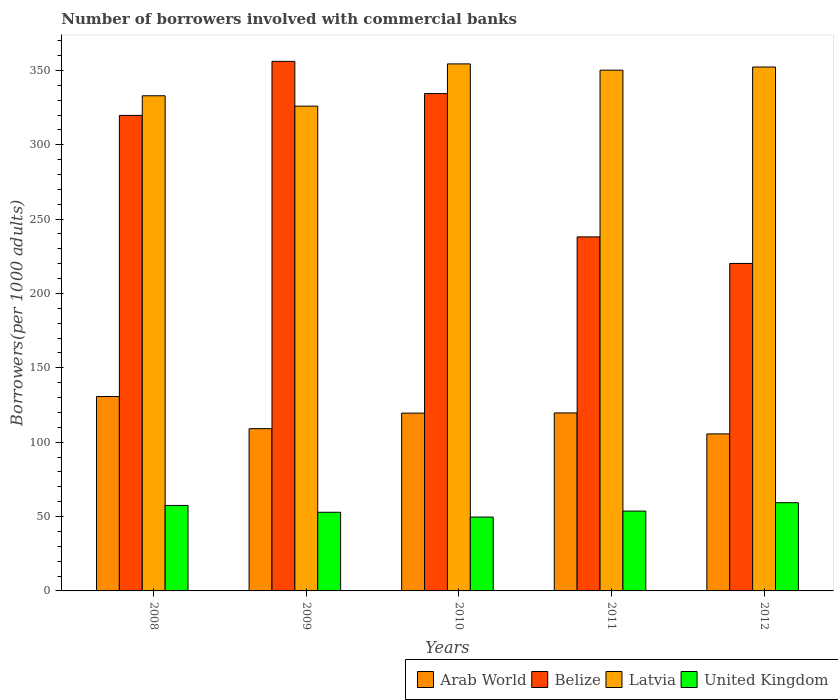How many different coloured bars are there?
Your response must be concise. 4. How many groups of bars are there?
Offer a terse response. 5. Are the number of bars per tick equal to the number of legend labels?
Your answer should be very brief. Yes. What is the number of borrowers involved with commercial banks in United Kingdom in 2010?
Offer a terse response. 49.65. Across all years, what is the maximum number of borrowers involved with commercial banks in Arab World?
Offer a very short reply. 130.7. Across all years, what is the minimum number of borrowers involved with commercial banks in Belize?
Your answer should be very brief. 220.2. What is the total number of borrowers involved with commercial banks in Arab World in the graph?
Your answer should be compact. 584.6. What is the difference between the number of borrowers involved with commercial banks in United Kingdom in 2008 and that in 2011?
Your response must be concise. 3.79. What is the difference between the number of borrowers involved with commercial banks in Arab World in 2008 and the number of borrowers involved with commercial banks in Belize in 2009?
Ensure brevity in your answer.  -225.37. What is the average number of borrowers involved with commercial banks in United Kingdom per year?
Give a very brief answer. 54.6. In the year 2011, what is the difference between the number of borrowers involved with commercial banks in United Kingdom and number of borrowers involved with commercial banks in Arab World?
Keep it short and to the point. -66. What is the ratio of the number of borrowers involved with commercial banks in United Kingdom in 2008 to that in 2011?
Your answer should be compact. 1.07. Is the number of borrowers involved with commercial banks in Arab World in 2008 less than that in 2011?
Keep it short and to the point. No. Is the difference between the number of borrowers involved with commercial banks in United Kingdom in 2009 and 2010 greater than the difference between the number of borrowers involved with commercial banks in Arab World in 2009 and 2010?
Keep it short and to the point. Yes. What is the difference between the highest and the second highest number of borrowers involved with commercial banks in Belize?
Give a very brief answer. 21.67. What is the difference between the highest and the lowest number of borrowers involved with commercial banks in Belize?
Offer a terse response. 135.87. Is the sum of the number of borrowers involved with commercial banks in Latvia in 2009 and 2012 greater than the maximum number of borrowers involved with commercial banks in United Kingdom across all years?
Your answer should be very brief. Yes. Is it the case that in every year, the sum of the number of borrowers involved with commercial banks in United Kingdom and number of borrowers involved with commercial banks in Arab World is greater than the sum of number of borrowers involved with commercial banks in Latvia and number of borrowers involved with commercial banks in Belize?
Offer a very short reply. No. What does the 3rd bar from the left in 2011 represents?
Give a very brief answer. Latvia. What does the 4th bar from the right in 2012 represents?
Offer a terse response. Arab World. Is it the case that in every year, the sum of the number of borrowers involved with commercial banks in United Kingdom and number of borrowers involved with commercial banks in Belize is greater than the number of borrowers involved with commercial banks in Latvia?
Give a very brief answer. No. How many bars are there?
Give a very brief answer. 20. Are all the bars in the graph horizontal?
Provide a short and direct response. No. How many years are there in the graph?
Offer a terse response. 5. What is the difference between two consecutive major ticks on the Y-axis?
Your answer should be very brief. 50. Does the graph contain grids?
Provide a succinct answer. No. Where does the legend appear in the graph?
Your response must be concise. Bottom right. How many legend labels are there?
Offer a terse response. 4. What is the title of the graph?
Your answer should be very brief. Number of borrowers involved with commercial banks. Does "Turkmenistan" appear as one of the legend labels in the graph?
Your answer should be compact. No. What is the label or title of the Y-axis?
Your answer should be compact. Borrowers(per 1000 adults). What is the Borrowers(per 1000 adults) of Arab World in 2008?
Your response must be concise. 130.7. What is the Borrowers(per 1000 adults) of Belize in 2008?
Your response must be concise. 319.74. What is the Borrowers(per 1000 adults) in Latvia in 2008?
Your answer should be compact. 332.93. What is the Borrowers(per 1000 adults) in United Kingdom in 2008?
Make the answer very short. 57.47. What is the Borrowers(per 1000 adults) in Arab World in 2009?
Ensure brevity in your answer.  109.1. What is the Borrowers(per 1000 adults) of Belize in 2009?
Your response must be concise. 356.07. What is the Borrowers(per 1000 adults) of Latvia in 2009?
Your response must be concise. 325.95. What is the Borrowers(per 1000 adults) in United Kingdom in 2009?
Offer a very short reply. 52.88. What is the Borrowers(per 1000 adults) of Arab World in 2010?
Keep it short and to the point. 119.55. What is the Borrowers(per 1000 adults) in Belize in 2010?
Provide a succinct answer. 334.41. What is the Borrowers(per 1000 adults) in Latvia in 2010?
Offer a terse response. 354.36. What is the Borrowers(per 1000 adults) in United Kingdom in 2010?
Keep it short and to the point. 49.65. What is the Borrowers(per 1000 adults) of Arab World in 2011?
Ensure brevity in your answer.  119.68. What is the Borrowers(per 1000 adults) in Belize in 2011?
Provide a short and direct response. 238.05. What is the Borrowers(per 1000 adults) in Latvia in 2011?
Offer a terse response. 350.14. What is the Borrowers(per 1000 adults) in United Kingdom in 2011?
Give a very brief answer. 53.68. What is the Borrowers(per 1000 adults) of Arab World in 2012?
Give a very brief answer. 105.58. What is the Borrowers(per 1000 adults) of Belize in 2012?
Ensure brevity in your answer.  220.2. What is the Borrowers(per 1000 adults) in Latvia in 2012?
Offer a very short reply. 352.26. What is the Borrowers(per 1000 adults) of United Kingdom in 2012?
Your response must be concise. 59.32. Across all years, what is the maximum Borrowers(per 1000 adults) of Arab World?
Make the answer very short. 130.7. Across all years, what is the maximum Borrowers(per 1000 adults) of Belize?
Make the answer very short. 356.07. Across all years, what is the maximum Borrowers(per 1000 adults) in Latvia?
Ensure brevity in your answer.  354.36. Across all years, what is the maximum Borrowers(per 1000 adults) in United Kingdom?
Provide a succinct answer. 59.32. Across all years, what is the minimum Borrowers(per 1000 adults) of Arab World?
Your answer should be very brief. 105.58. Across all years, what is the minimum Borrowers(per 1000 adults) in Belize?
Ensure brevity in your answer.  220.2. Across all years, what is the minimum Borrowers(per 1000 adults) of Latvia?
Provide a succinct answer. 325.95. Across all years, what is the minimum Borrowers(per 1000 adults) in United Kingdom?
Offer a very short reply. 49.65. What is the total Borrowers(per 1000 adults) of Arab World in the graph?
Keep it short and to the point. 584.6. What is the total Borrowers(per 1000 adults) of Belize in the graph?
Offer a terse response. 1468.47. What is the total Borrowers(per 1000 adults) in Latvia in the graph?
Give a very brief answer. 1715.64. What is the total Borrowers(per 1000 adults) of United Kingdom in the graph?
Your answer should be very brief. 273. What is the difference between the Borrowers(per 1000 adults) in Arab World in 2008 and that in 2009?
Your answer should be compact. 21.6. What is the difference between the Borrowers(per 1000 adults) in Belize in 2008 and that in 2009?
Give a very brief answer. -36.33. What is the difference between the Borrowers(per 1000 adults) in Latvia in 2008 and that in 2009?
Provide a short and direct response. 6.98. What is the difference between the Borrowers(per 1000 adults) in United Kingdom in 2008 and that in 2009?
Keep it short and to the point. 4.59. What is the difference between the Borrowers(per 1000 adults) in Arab World in 2008 and that in 2010?
Provide a short and direct response. 11.15. What is the difference between the Borrowers(per 1000 adults) in Belize in 2008 and that in 2010?
Give a very brief answer. -14.67. What is the difference between the Borrowers(per 1000 adults) in Latvia in 2008 and that in 2010?
Your answer should be very brief. -21.43. What is the difference between the Borrowers(per 1000 adults) of United Kingdom in 2008 and that in 2010?
Your answer should be very brief. 7.83. What is the difference between the Borrowers(per 1000 adults) in Arab World in 2008 and that in 2011?
Provide a succinct answer. 11.02. What is the difference between the Borrowers(per 1000 adults) of Belize in 2008 and that in 2011?
Give a very brief answer. 81.69. What is the difference between the Borrowers(per 1000 adults) of Latvia in 2008 and that in 2011?
Give a very brief answer. -17.21. What is the difference between the Borrowers(per 1000 adults) in United Kingdom in 2008 and that in 2011?
Offer a very short reply. 3.79. What is the difference between the Borrowers(per 1000 adults) in Arab World in 2008 and that in 2012?
Your response must be concise. 25.12. What is the difference between the Borrowers(per 1000 adults) in Belize in 2008 and that in 2012?
Your answer should be compact. 99.53. What is the difference between the Borrowers(per 1000 adults) of Latvia in 2008 and that in 2012?
Make the answer very short. -19.32. What is the difference between the Borrowers(per 1000 adults) of United Kingdom in 2008 and that in 2012?
Give a very brief answer. -1.85. What is the difference between the Borrowers(per 1000 adults) in Arab World in 2009 and that in 2010?
Your answer should be compact. -10.45. What is the difference between the Borrowers(per 1000 adults) in Belize in 2009 and that in 2010?
Ensure brevity in your answer.  21.67. What is the difference between the Borrowers(per 1000 adults) of Latvia in 2009 and that in 2010?
Give a very brief answer. -28.41. What is the difference between the Borrowers(per 1000 adults) in United Kingdom in 2009 and that in 2010?
Your answer should be compact. 3.23. What is the difference between the Borrowers(per 1000 adults) in Arab World in 2009 and that in 2011?
Provide a short and direct response. -10.58. What is the difference between the Borrowers(per 1000 adults) in Belize in 2009 and that in 2011?
Offer a terse response. 118.03. What is the difference between the Borrowers(per 1000 adults) in Latvia in 2009 and that in 2011?
Your response must be concise. -24.19. What is the difference between the Borrowers(per 1000 adults) of United Kingdom in 2009 and that in 2011?
Provide a succinct answer. -0.8. What is the difference between the Borrowers(per 1000 adults) in Arab World in 2009 and that in 2012?
Your response must be concise. 3.52. What is the difference between the Borrowers(per 1000 adults) of Belize in 2009 and that in 2012?
Offer a terse response. 135.87. What is the difference between the Borrowers(per 1000 adults) in Latvia in 2009 and that in 2012?
Offer a terse response. -26.3. What is the difference between the Borrowers(per 1000 adults) of United Kingdom in 2009 and that in 2012?
Give a very brief answer. -6.44. What is the difference between the Borrowers(per 1000 adults) of Arab World in 2010 and that in 2011?
Keep it short and to the point. -0.13. What is the difference between the Borrowers(per 1000 adults) in Belize in 2010 and that in 2011?
Make the answer very short. 96.36. What is the difference between the Borrowers(per 1000 adults) of Latvia in 2010 and that in 2011?
Your response must be concise. 4.22. What is the difference between the Borrowers(per 1000 adults) of United Kingdom in 2010 and that in 2011?
Offer a very short reply. -4.03. What is the difference between the Borrowers(per 1000 adults) in Arab World in 2010 and that in 2012?
Provide a short and direct response. 13.97. What is the difference between the Borrowers(per 1000 adults) of Belize in 2010 and that in 2012?
Make the answer very short. 114.2. What is the difference between the Borrowers(per 1000 adults) in Latvia in 2010 and that in 2012?
Give a very brief answer. 2.11. What is the difference between the Borrowers(per 1000 adults) of United Kingdom in 2010 and that in 2012?
Give a very brief answer. -9.67. What is the difference between the Borrowers(per 1000 adults) of Arab World in 2011 and that in 2012?
Provide a short and direct response. 14.1. What is the difference between the Borrowers(per 1000 adults) of Belize in 2011 and that in 2012?
Offer a very short reply. 17.84. What is the difference between the Borrowers(per 1000 adults) in Latvia in 2011 and that in 2012?
Your answer should be compact. -2.12. What is the difference between the Borrowers(per 1000 adults) in United Kingdom in 2011 and that in 2012?
Give a very brief answer. -5.64. What is the difference between the Borrowers(per 1000 adults) in Arab World in 2008 and the Borrowers(per 1000 adults) in Belize in 2009?
Give a very brief answer. -225.38. What is the difference between the Borrowers(per 1000 adults) of Arab World in 2008 and the Borrowers(per 1000 adults) of Latvia in 2009?
Offer a very short reply. -195.25. What is the difference between the Borrowers(per 1000 adults) in Arab World in 2008 and the Borrowers(per 1000 adults) in United Kingdom in 2009?
Offer a very short reply. 77.82. What is the difference between the Borrowers(per 1000 adults) in Belize in 2008 and the Borrowers(per 1000 adults) in Latvia in 2009?
Provide a short and direct response. -6.21. What is the difference between the Borrowers(per 1000 adults) of Belize in 2008 and the Borrowers(per 1000 adults) of United Kingdom in 2009?
Make the answer very short. 266.86. What is the difference between the Borrowers(per 1000 adults) in Latvia in 2008 and the Borrowers(per 1000 adults) in United Kingdom in 2009?
Keep it short and to the point. 280.05. What is the difference between the Borrowers(per 1000 adults) of Arab World in 2008 and the Borrowers(per 1000 adults) of Belize in 2010?
Your answer should be compact. -203.71. What is the difference between the Borrowers(per 1000 adults) in Arab World in 2008 and the Borrowers(per 1000 adults) in Latvia in 2010?
Keep it short and to the point. -223.66. What is the difference between the Borrowers(per 1000 adults) of Arab World in 2008 and the Borrowers(per 1000 adults) of United Kingdom in 2010?
Your answer should be very brief. 81.05. What is the difference between the Borrowers(per 1000 adults) in Belize in 2008 and the Borrowers(per 1000 adults) in Latvia in 2010?
Offer a terse response. -34.62. What is the difference between the Borrowers(per 1000 adults) of Belize in 2008 and the Borrowers(per 1000 adults) of United Kingdom in 2010?
Your answer should be very brief. 270.09. What is the difference between the Borrowers(per 1000 adults) of Latvia in 2008 and the Borrowers(per 1000 adults) of United Kingdom in 2010?
Make the answer very short. 283.29. What is the difference between the Borrowers(per 1000 adults) in Arab World in 2008 and the Borrowers(per 1000 adults) in Belize in 2011?
Give a very brief answer. -107.35. What is the difference between the Borrowers(per 1000 adults) of Arab World in 2008 and the Borrowers(per 1000 adults) of Latvia in 2011?
Ensure brevity in your answer.  -219.44. What is the difference between the Borrowers(per 1000 adults) of Arab World in 2008 and the Borrowers(per 1000 adults) of United Kingdom in 2011?
Your answer should be very brief. 77.02. What is the difference between the Borrowers(per 1000 adults) of Belize in 2008 and the Borrowers(per 1000 adults) of Latvia in 2011?
Provide a short and direct response. -30.4. What is the difference between the Borrowers(per 1000 adults) in Belize in 2008 and the Borrowers(per 1000 adults) in United Kingdom in 2011?
Provide a succinct answer. 266.06. What is the difference between the Borrowers(per 1000 adults) in Latvia in 2008 and the Borrowers(per 1000 adults) in United Kingdom in 2011?
Your answer should be very brief. 279.25. What is the difference between the Borrowers(per 1000 adults) of Arab World in 2008 and the Borrowers(per 1000 adults) of Belize in 2012?
Ensure brevity in your answer.  -89.51. What is the difference between the Borrowers(per 1000 adults) in Arab World in 2008 and the Borrowers(per 1000 adults) in Latvia in 2012?
Your answer should be very brief. -221.56. What is the difference between the Borrowers(per 1000 adults) of Arab World in 2008 and the Borrowers(per 1000 adults) of United Kingdom in 2012?
Your answer should be very brief. 71.38. What is the difference between the Borrowers(per 1000 adults) in Belize in 2008 and the Borrowers(per 1000 adults) in Latvia in 2012?
Your response must be concise. -32.52. What is the difference between the Borrowers(per 1000 adults) in Belize in 2008 and the Borrowers(per 1000 adults) in United Kingdom in 2012?
Make the answer very short. 260.42. What is the difference between the Borrowers(per 1000 adults) of Latvia in 2008 and the Borrowers(per 1000 adults) of United Kingdom in 2012?
Provide a short and direct response. 273.61. What is the difference between the Borrowers(per 1000 adults) of Arab World in 2009 and the Borrowers(per 1000 adults) of Belize in 2010?
Offer a terse response. -225.31. What is the difference between the Borrowers(per 1000 adults) in Arab World in 2009 and the Borrowers(per 1000 adults) in Latvia in 2010?
Make the answer very short. -245.26. What is the difference between the Borrowers(per 1000 adults) in Arab World in 2009 and the Borrowers(per 1000 adults) in United Kingdom in 2010?
Provide a short and direct response. 59.45. What is the difference between the Borrowers(per 1000 adults) of Belize in 2009 and the Borrowers(per 1000 adults) of Latvia in 2010?
Keep it short and to the point. 1.71. What is the difference between the Borrowers(per 1000 adults) in Belize in 2009 and the Borrowers(per 1000 adults) in United Kingdom in 2010?
Your answer should be very brief. 306.42. What is the difference between the Borrowers(per 1000 adults) in Latvia in 2009 and the Borrowers(per 1000 adults) in United Kingdom in 2010?
Offer a very short reply. 276.3. What is the difference between the Borrowers(per 1000 adults) in Arab World in 2009 and the Borrowers(per 1000 adults) in Belize in 2011?
Ensure brevity in your answer.  -128.95. What is the difference between the Borrowers(per 1000 adults) of Arab World in 2009 and the Borrowers(per 1000 adults) of Latvia in 2011?
Give a very brief answer. -241.04. What is the difference between the Borrowers(per 1000 adults) in Arab World in 2009 and the Borrowers(per 1000 adults) in United Kingdom in 2011?
Give a very brief answer. 55.42. What is the difference between the Borrowers(per 1000 adults) of Belize in 2009 and the Borrowers(per 1000 adults) of Latvia in 2011?
Your answer should be very brief. 5.93. What is the difference between the Borrowers(per 1000 adults) of Belize in 2009 and the Borrowers(per 1000 adults) of United Kingdom in 2011?
Your answer should be compact. 302.39. What is the difference between the Borrowers(per 1000 adults) in Latvia in 2009 and the Borrowers(per 1000 adults) in United Kingdom in 2011?
Your answer should be compact. 272.27. What is the difference between the Borrowers(per 1000 adults) of Arab World in 2009 and the Borrowers(per 1000 adults) of Belize in 2012?
Offer a very short reply. -111.11. What is the difference between the Borrowers(per 1000 adults) of Arab World in 2009 and the Borrowers(per 1000 adults) of Latvia in 2012?
Give a very brief answer. -243.16. What is the difference between the Borrowers(per 1000 adults) in Arab World in 2009 and the Borrowers(per 1000 adults) in United Kingdom in 2012?
Give a very brief answer. 49.78. What is the difference between the Borrowers(per 1000 adults) of Belize in 2009 and the Borrowers(per 1000 adults) of Latvia in 2012?
Offer a terse response. 3.82. What is the difference between the Borrowers(per 1000 adults) in Belize in 2009 and the Borrowers(per 1000 adults) in United Kingdom in 2012?
Make the answer very short. 296.75. What is the difference between the Borrowers(per 1000 adults) of Latvia in 2009 and the Borrowers(per 1000 adults) of United Kingdom in 2012?
Your answer should be very brief. 266.63. What is the difference between the Borrowers(per 1000 adults) of Arab World in 2010 and the Borrowers(per 1000 adults) of Belize in 2011?
Offer a very short reply. -118.5. What is the difference between the Borrowers(per 1000 adults) in Arab World in 2010 and the Borrowers(per 1000 adults) in Latvia in 2011?
Keep it short and to the point. -230.59. What is the difference between the Borrowers(per 1000 adults) in Arab World in 2010 and the Borrowers(per 1000 adults) in United Kingdom in 2011?
Provide a succinct answer. 65.87. What is the difference between the Borrowers(per 1000 adults) in Belize in 2010 and the Borrowers(per 1000 adults) in Latvia in 2011?
Make the answer very short. -15.73. What is the difference between the Borrowers(per 1000 adults) in Belize in 2010 and the Borrowers(per 1000 adults) in United Kingdom in 2011?
Your answer should be very brief. 280.73. What is the difference between the Borrowers(per 1000 adults) in Latvia in 2010 and the Borrowers(per 1000 adults) in United Kingdom in 2011?
Keep it short and to the point. 300.68. What is the difference between the Borrowers(per 1000 adults) of Arab World in 2010 and the Borrowers(per 1000 adults) of Belize in 2012?
Provide a short and direct response. -100.65. What is the difference between the Borrowers(per 1000 adults) of Arab World in 2010 and the Borrowers(per 1000 adults) of Latvia in 2012?
Offer a terse response. -232.71. What is the difference between the Borrowers(per 1000 adults) in Arab World in 2010 and the Borrowers(per 1000 adults) in United Kingdom in 2012?
Your response must be concise. 60.23. What is the difference between the Borrowers(per 1000 adults) of Belize in 2010 and the Borrowers(per 1000 adults) of Latvia in 2012?
Keep it short and to the point. -17.85. What is the difference between the Borrowers(per 1000 adults) of Belize in 2010 and the Borrowers(per 1000 adults) of United Kingdom in 2012?
Make the answer very short. 275.09. What is the difference between the Borrowers(per 1000 adults) in Latvia in 2010 and the Borrowers(per 1000 adults) in United Kingdom in 2012?
Offer a very short reply. 295.04. What is the difference between the Borrowers(per 1000 adults) of Arab World in 2011 and the Borrowers(per 1000 adults) of Belize in 2012?
Make the answer very short. -100.52. What is the difference between the Borrowers(per 1000 adults) of Arab World in 2011 and the Borrowers(per 1000 adults) of Latvia in 2012?
Your answer should be very brief. -232.58. What is the difference between the Borrowers(per 1000 adults) of Arab World in 2011 and the Borrowers(per 1000 adults) of United Kingdom in 2012?
Provide a succinct answer. 60.36. What is the difference between the Borrowers(per 1000 adults) of Belize in 2011 and the Borrowers(per 1000 adults) of Latvia in 2012?
Give a very brief answer. -114.21. What is the difference between the Borrowers(per 1000 adults) of Belize in 2011 and the Borrowers(per 1000 adults) of United Kingdom in 2012?
Your answer should be very brief. 178.72. What is the difference between the Borrowers(per 1000 adults) in Latvia in 2011 and the Borrowers(per 1000 adults) in United Kingdom in 2012?
Provide a succinct answer. 290.82. What is the average Borrowers(per 1000 adults) in Arab World per year?
Ensure brevity in your answer.  116.92. What is the average Borrowers(per 1000 adults) of Belize per year?
Provide a short and direct response. 293.69. What is the average Borrowers(per 1000 adults) in Latvia per year?
Make the answer very short. 343.13. What is the average Borrowers(per 1000 adults) of United Kingdom per year?
Offer a very short reply. 54.6. In the year 2008, what is the difference between the Borrowers(per 1000 adults) in Arab World and Borrowers(per 1000 adults) in Belize?
Offer a very short reply. -189.04. In the year 2008, what is the difference between the Borrowers(per 1000 adults) of Arab World and Borrowers(per 1000 adults) of Latvia?
Keep it short and to the point. -202.24. In the year 2008, what is the difference between the Borrowers(per 1000 adults) of Arab World and Borrowers(per 1000 adults) of United Kingdom?
Ensure brevity in your answer.  73.22. In the year 2008, what is the difference between the Borrowers(per 1000 adults) of Belize and Borrowers(per 1000 adults) of Latvia?
Your response must be concise. -13.19. In the year 2008, what is the difference between the Borrowers(per 1000 adults) of Belize and Borrowers(per 1000 adults) of United Kingdom?
Keep it short and to the point. 262.26. In the year 2008, what is the difference between the Borrowers(per 1000 adults) of Latvia and Borrowers(per 1000 adults) of United Kingdom?
Provide a short and direct response. 275.46. In the year 2009, what is the difference between the Borrowers(per 1000 adults) of Arab World and Borrowers(per 1000 adults) of Belize?
Your answer should be compact. -246.98. In the year 2009, what is the difference between the Borrowers(per 1000 adults) in Arab World and Borrowers(per 1000 adults) in Latvia?
Your answer should be very brief. -216.85. In the year 2009, what is the difference between the Borrowers(per 1000 adults) of Arab World and Borrowers(per 1000 adults) of United Kingdom?
Ensure brevity in your answer.  56.22. In the year 2009, what is the difference between the Borrowers(per 1000 adults) of Belize and Borrowers(per 1000 adults) of Latvia?
Ensure brevity in your answer.  30.12. In the year 2009, what is the difference between the Borrowers(per 1000 adults) of Belize and Borrowers(per 1000 adults) of United Kingdom?
Give a very brief answer. 303.19. In the year 2009, what is the difference between the Borrowers(per 1000 adults) in Latvia and Borrowers(per 1000 adults) in United Kingdom?
Keep it short and to the point. 273.07. In the year 2010, what is the difference between the Borrowers(per 1000 adults) of Arab World and Borrowers(per 1000 adults) of Belize?
Give a very brief answer. -214.86. In the year 2010, what is the difference between the Borrowers(per 1000 adults) of Arab World and Borrowers(per 1000 adults) of Latvia?
Ensure brevity in your answer.  -234.81. In the year 2010, what is the difference between the Borrowers(per 1000 adults) of Arab World and Borrowers(per 1000 adults) of United Kingdom?
Your answer should be very brief. 69.9. In the year 2010, what is the difference between the Borrowers(per 1000 adults) in Belize and Borrowers(per 1000 adults) in Latvia?
Make the answer very short. -19.96. In the year 2010, what is the difference between the Borrowers(per 1000 adults) in Belize and Borrowers(per 1000 adults) in United Kingdom?
Offer a very short reply. 284.76. In the year 2010, what is the difference between the Borrowers(per 1000 adults) in Latvia and Borrowers(per 1000 adults) in United Kingdom?
Your answer should be very brief. 304.71. In the year 2011, what is the difference between the Borrowers(per 1000 adults) of Arab World and Borrowers(per 1000 adults) of Belize?
Your answer should be compact. -118.37. In the year 2011, what is the difference between the Borrowers(per 1000 adults) of Arab World and Borrowers(per 1000 adults) of Latvia?
Your answer should be compact. -230.46. In the year 2011, what is the difference between the Borrowers(per 1000 adults) in Arab World and Borrowers(per 1000 adults) in United Kingdom?
Provide a succinct answer. 66. In the year 2011, what is the difference between the Borrowers(per 1000 adults) of Belize and Borrowers(per 1000 adults) of Latvia?
Provide a short and direct response. -112.09. In the year 2011, what is the difference between the Borrowers(per 1000 adults) in Belize and Borrowers(per 1000 adults) in United Kingdom?
Provide a short and direct response. 184.37. In the year 2011, what is the difference between the Borrowers(per 1000 adults) of Latvia and Borrowers(per 1000 adults) of United Kingdom?
Your response must be concise. 296.46. In the year 2012, what is the difference between the Borrowers(per 1000 adults) of Arab World and Borrowers(per 1000 adults) of Belize?
Give a very brief answer. -114.62. In the year 2012, what is the difference between the Borrowers(per 1000 adults) in Arab World and Borrowers(per 1000 adults) in Latvia?
Offer a terse response. -246.68. In the year 2012, what is the difference between the Borrowers(per 1000 adults) in Arab World and Borrowers(per 1000 adults) in United Kingdom?
Give a very brief answer. 46.26. In the year 2012, what is the difference between the Borrowers(per 1000 adults) in Belize and Borrowers(per 1000 adults) in Latvia?
Your response must be concise. -132.05. In the year 2012, what is the difference between the Borrowers(per 1000 adults) of Belize and Borrowers(per 1000 adults) of United Kingdom?
Your answer should be compact. 160.88. In the year 2012, what is the difference between the Borrowers(per 1000 adults) in Latvia and Borrowers(per 1000 adults) in United Kingdom?
Your answer should be very brief. 292.94. What is the ratio of the Borrowers(per 1000 adults) in Arab World in 2008 to that in 2009?
Your answer should be very brief. 1.2. What is the ratio of the Borrowers(per 1000 adults) in Belize in 2008 to that in 2009?
Make the answer very short. 0.9. What is the ratio of the Borrowers(per 1000 adults) of Latvia in 2008 to that in 2009?
Your answer should be very brief. 1.02. What is the ratio of the Borrowers(per 1000 adults) in United Kingdom in 2008 to that in 2009?
Offer a very short reply. 1.09. What is the ratio of the Borrowers(per 1000 adults) of Arab World in 2008 to that in 2010?
Give a very brief answer. 1.09. What is the ratio of the Borrowers(per 1000 adults) of Belize in 2008 to that in 2010?
Offer a terse response. 0.96. What is the ratio of the Borrowers(per 1000 adults) in Latvia in 2008 to that in 2010?
Provide a short and direct response. 0.94. What is the ratio of the Borrowers(per 1000 adults) of United Kingdom in 2008 to that in 2010?
Provide a succinct answer. 1.16. What is the ratio of the Borrowers(per 1000 adults) in Arab World in 2008 to that in 2011?
Provide a short and direct response. 1.09. What is the ratio of the Borrowers(per 1000 adults) in Belize in 2008 to that in 2011?
Offer a terse response. 1.34. What is the ratio of the Borrowers(per 1000 adults) of Latvia in 2008 to that in 2011?
Provide a short and direct response. 0.95. What is the ratio of the Borrowers(per 1000 adults) in United Kingdom in 2008 to that in 2011?
Your answer should be compact. 1.07. What is the ratio of the Borrowers(per 1000 adults) of Arab World in 2008 to that in 2012?
Your answer should be very brief. 1.24. What is the ratio of the Borrowers(per 1000 adults) of Belize in 2008 to that in 2012?
Offer a very short reply. 1.45. What is the ratio of the Borrowers(per 1000 adults) of Latvia in 2008 to that in 2012?
Your response must be concise. 0.95. What is the ratio of the Borrowers(per 1000 adults) of United Kingdom in 2008 to that in 2012?
Give a very brief answer. 0.97. What is the ratio of the Borrowers(per 1000 adults) of Arab World in 2009 to that in 2010?
Give a very brief answer. 0.91. What is the ratio of the Borrowers(per 1000 adults) of Belize in 2009 to that in 2010?
Ensure brevity in your answer.  1.06. What is the ratio of the Borrowers(per 1000 adults) in Latvia in 2009 to that in 2010?
Offer a very short reply. 0.92. What is the ratio of the Borrowers(per 1000 adults) of United Kingdom in 2009 to that in 2010?
Ensure brevity in your answer.  1.07. What is the ratio of the Borrowers(per 1000 adults) in Arab World in 2009 to that in 2011?
Provide a short and direct response. 0.91. What is the ratio of the Borrowers(per 1000 adults) of Belize in 2009 to that in 2011?
Provide a short and direct response. 1.5. What is the ratio of the Borrowers(per 1000 adults) of Latvia in 2009 to that in 2011?
Make the answer very short. 0.93. What is the ratio of the Borrowers(per 1000 adults) in United Kingdom in 2009 to that in 2011?
Make the answer very short. 0.99. What is the ratio of the Borrowers(per 1000 adults) in Arab World in 2009 to that in 2012?
Make the answer very short. 1.03. What is the ratio of the Borrowers(per 1000 adults) in Belize in 2009 to that in 2012?
Give a very brief answer. 1.62. What is the ratio of the Borrowers(per 1000 adults) of Latvia in 2009 to that in 2012?
Your response must be concise. 0.93. What is the ratio of the Borrowers(per 1000 adults) in United Kingdom in 2009 to that in 2012?
Keep it short and to the point. 0.89. What is the ratio of the Borrowers(per 1000 adults) of Arab World in 2010 to that in 2011?
Ensure brevity in your answer.  1. What is the ratio of the Borrowers(per 1000 adults) in Belize in 2010 to that in 2011?
Make the answer very short. 1.4. What is the ratio of the Borrowers(per 1000 adults) in Latvia in 2010 to that in 2011?
Offer a very short reply. 1.01. What is the ratio of the Borrowers(per 1000 adults) in United Kingdom in 2010 to that in 2011?
Make the answer very short. 0.92. What is the ratio of the Borrowers(per 1000 adults) of Arab World in 2010 to that in 2012?
Ensure brevity in your answer.  1.13. What is the ratio of the Borrowers(per 1000 adults) of Belize in 2010 to that in 2012?
Ensure brevity in your answer.  1.52. What is the ratio of the Borrowers(per 1000 adults) in Latvia in 2010 to that in 2012?
Make the answer very short. 1.01. What is the ratio of the Borrowers(per 1000 adults) of United Kingdom in 2010 to that in 2012?
Your answer should be compact. 0.84. What is the ratio of the Borrowers(per 1000 adults) of Arab World in 2011 to that in 2012?
Provide a succinct answer. 1.13. What is the ratio of the Borrowers(per 1000 adults) in Belize in 2011 to that in 2012?
Your response must be concise. 1.08. What is the ratio of the Borrowers(per 1000 adults) of United Kingdom in 2011 to that in 2012?
Provide a short and direct response. 0.9. What is the difference between the highest and the second highest Borrowers(per 1000 adults) in Arab World?
Your answer should be compact. 11.02. What is the difference between the highest and the second highest Borrowers(per 1000 adults) in Belize?
Ensure brevity in your answer.  21.67. What is the difference between the highest and the second highest Borrowers(per 1000 adults) of Latvia?
Provide a succinct answer. 2.11. What is the difference between the highest and the second highest Borrowers(per 1000 adults) of United Kingdom?
Your answer should be very brief. 1.85. What is the difference between the highest and the lowest Borrowers(per 1000 adults) of Arab World?
Ensure brevity in your answer.  25.12. What is the difference between the highest and the lowest Borrowers(per 1000 adults) in Belize?
Offer a very short reply. 135.87. What is the difference between the highest and the lowest Borrowers(per 1000 adults) in Latvia?
Offer a very short reply. 28.41. What is the difference between the highest and the lowest Borrowers(per 1000 adults) of United Kingdom?
Provide a succinct answer. 9.67. 